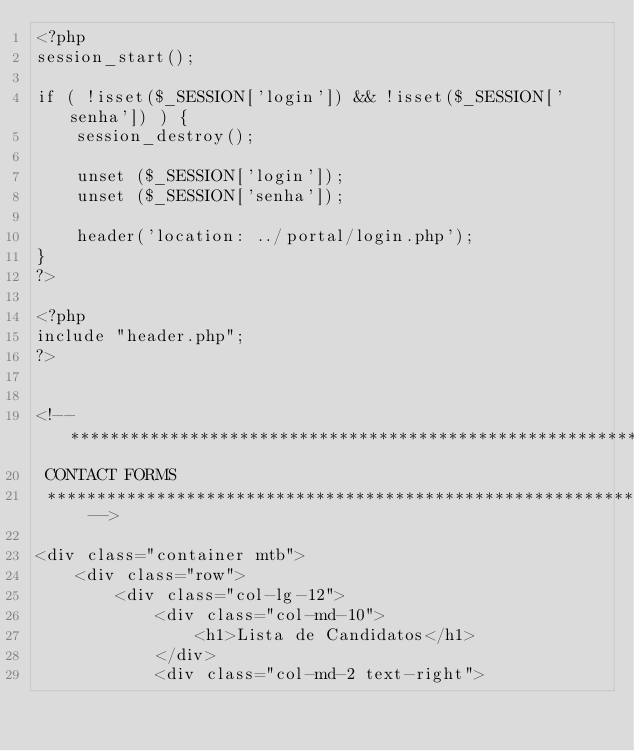Convert code to text. <code><loc_0><loc_0><loc_500><loc_500><_PHP_><?php
session_start();

if ( !isset($_SESSION['login']) && !isset($_SESSION['senha']) ) {
    session_destroy();

    unset ($_SESSION['login']);
    unset ($_SESSION['senha']);

    header('location: ../portal/login.php');
}
?>

<?php
include "header.php";
?>


<!-- *****************************************************************************************************************
 CONTACT FORMS
 ***************************************************************************************************************** -->

<div class="container mtb">
    <div class="row">
        <div class="col-lg-12">
            <div class="col-md-10">
                <h1>Lista de Candidatos</h1>
            </div>
            <div class="col-md-2 text-right"></code> 